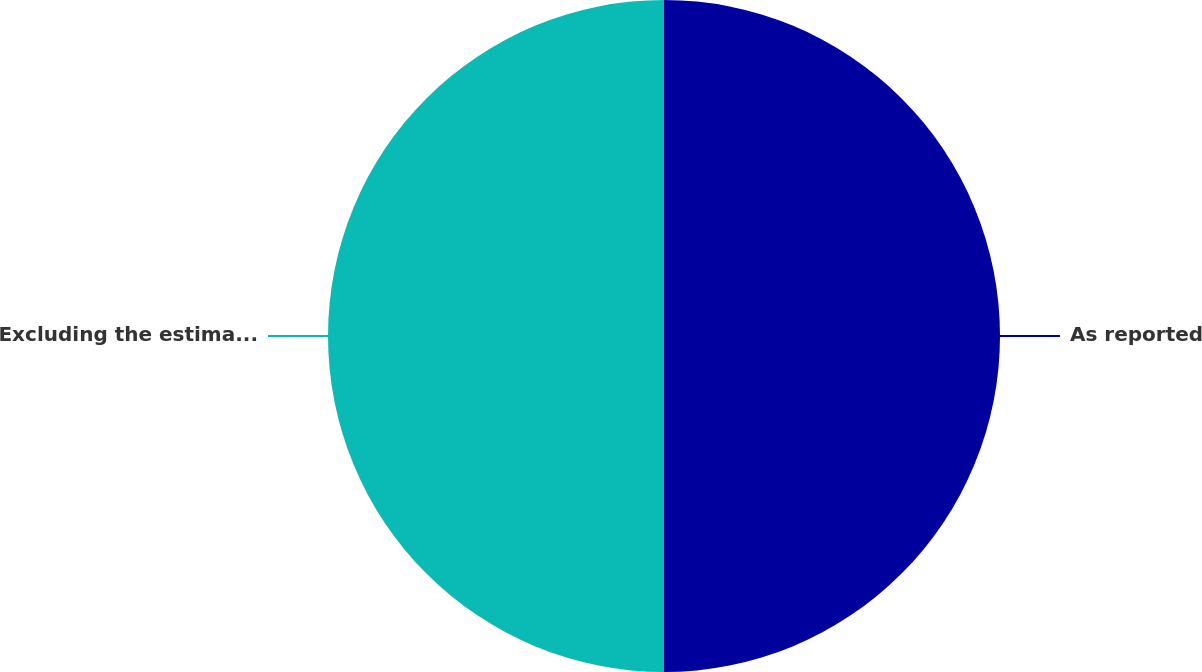<chart> <loc_0><loc_0><loc_500><loc_500><pie_chart><fcel>As reported<fcel>Excluding the estimated impact<nl><fcel>50.0%<fcel>50.0%<nl></chart> 